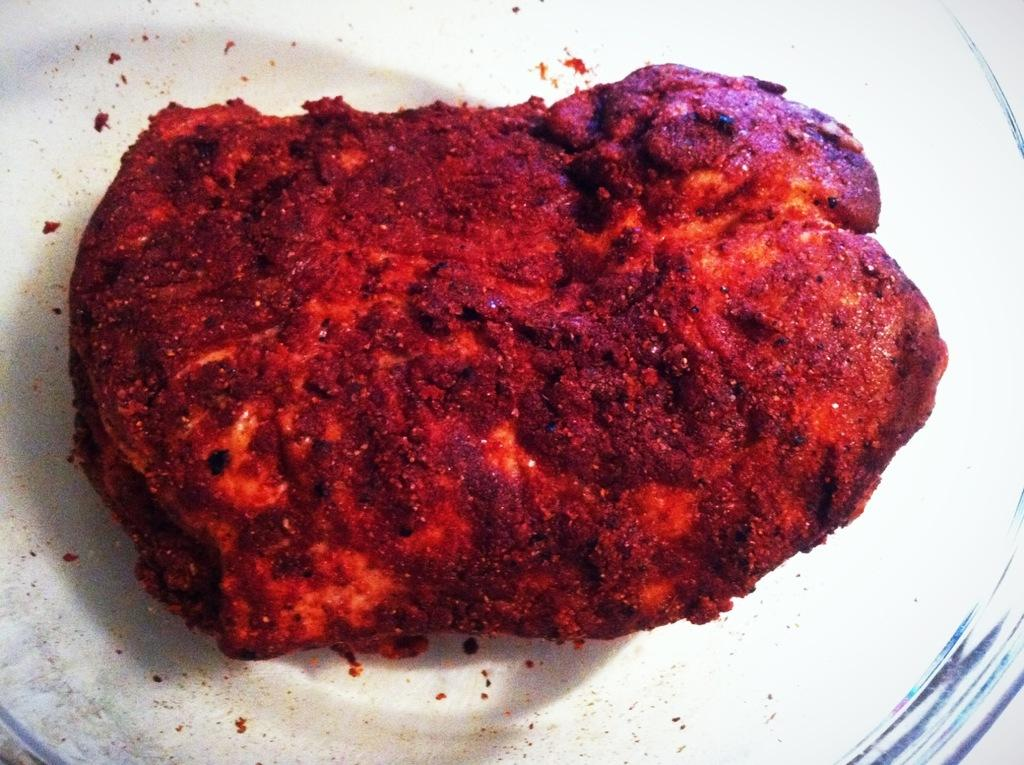What is the main subject of the image? The main subject of the image is food. How is the food presented in the image? The food is placed on a white color plate. What type of bat can be seen flying over the food in the image? There is no bat present in the image; it only features food on a white color plate. 